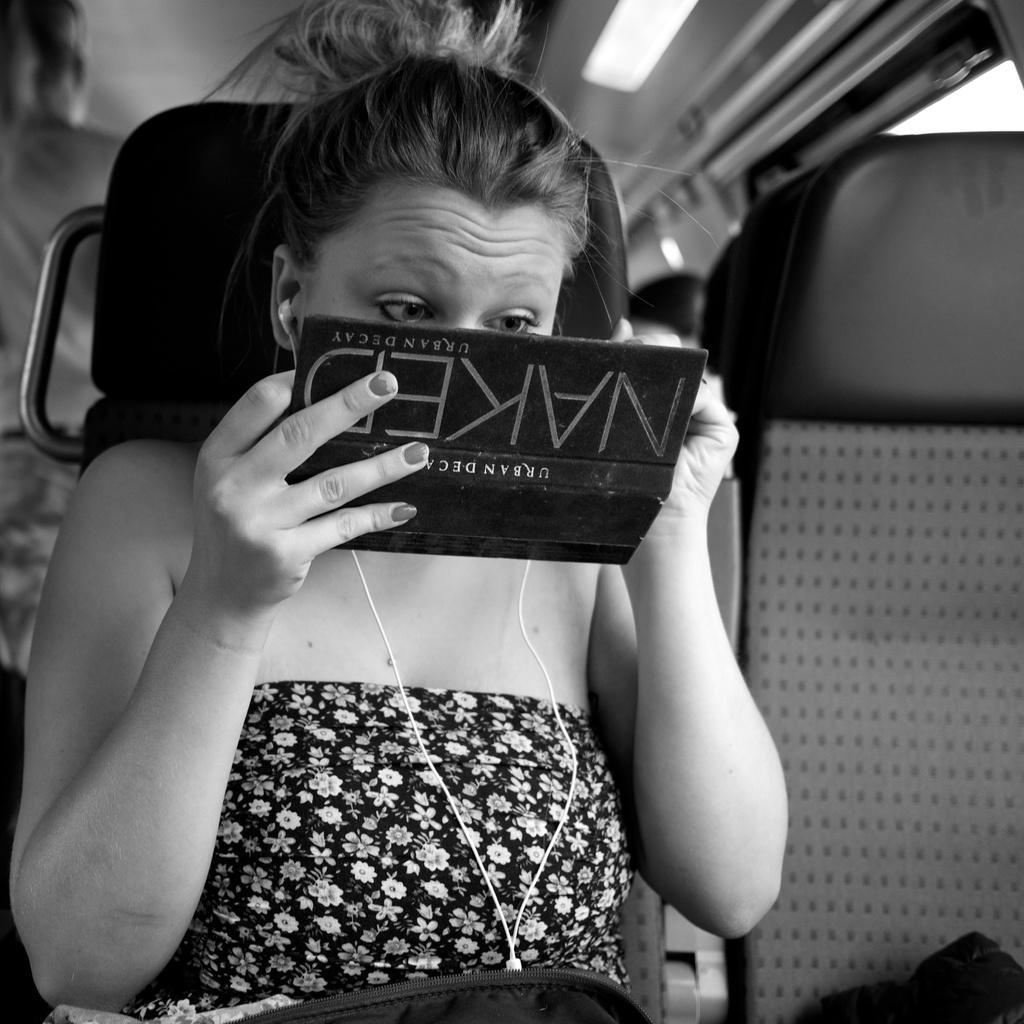In one or two sentences, can you explain what this image depicts? In this image, we can see a woman is holding a black color object and looking towards the object. She is sitting on a seat. Here we can see few seats and people. 